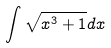Convert formula to latex. <formula><loc_0><loc_0><loc_500><loc_500>\int \sqrt { x ^ { 3 } + 1 } d x</formula> 